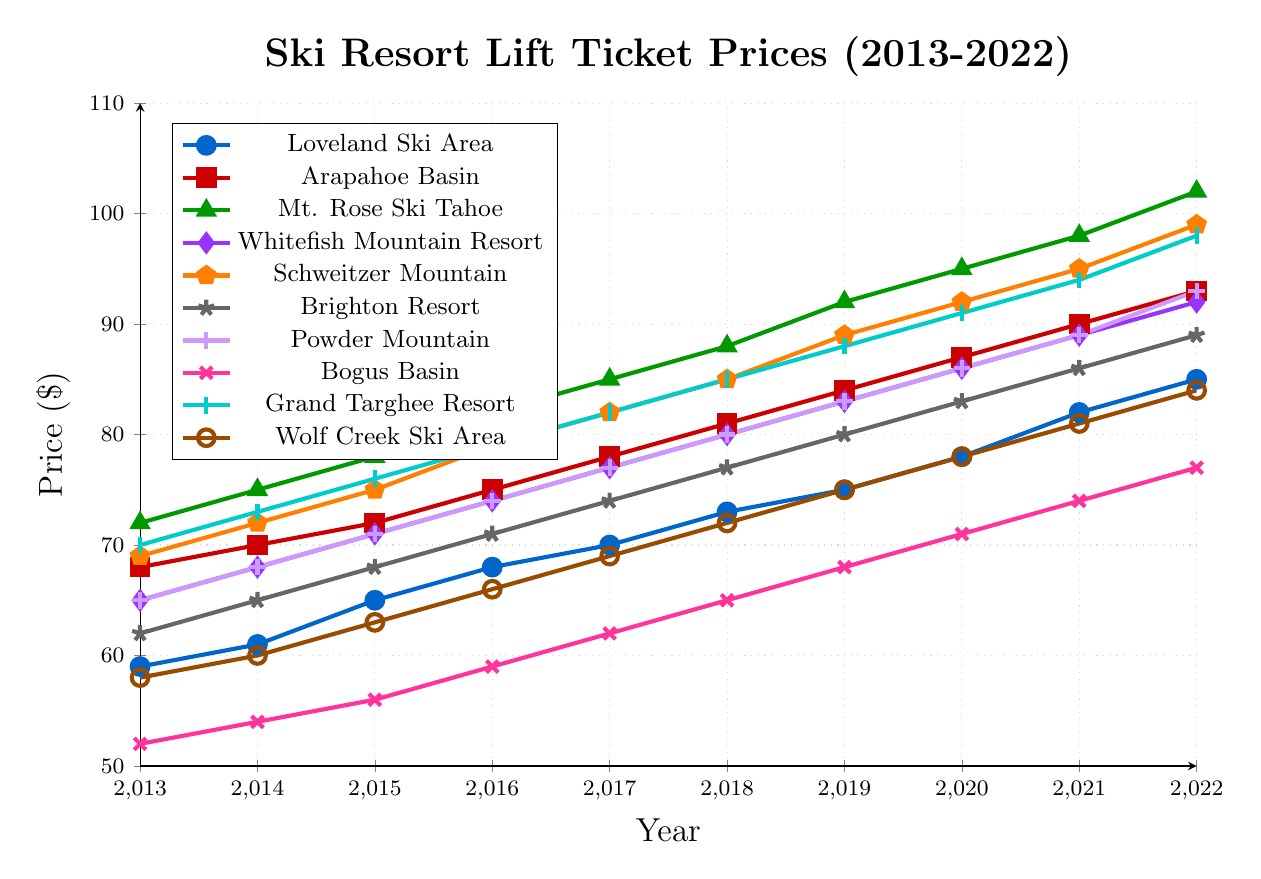Which resort had the lowest lift ticket price in 2013? Look for the data points from 2013 and identify the lowest value among them. Bogus Basin has the lowest ticket price in 2013 at $52.
Answer: Bogus Basin Which resort had the highest lift ticket price increase between 2013 and 2022? Calculate the difference between the 2022 and 2013 prices for all resorts. The largest increase is for Mt. Rose Ski Tahoe, which increased from $72 to $102, a $30 increase.
Answer: Mt. Rose Ski Tahoe What's the average lift ticket price for Loveland Ski Area over the 10 years? Sum up the prices for Loveland Ski Area from 2013 to 2022 and divide by 10. The sum is 716 and the average is 716/10 = 71.6.
Answer: 71.6 Which resort had more expensive lift tickets in 2022, Arapahoe Basin or Brighton Resort? Compare the price for Arapahoe Basin ($93) and Brighton Resort ($89) in 2022. Arapahoe Basin is more expensive.
Answer: Arapahoe Basin What is the color of the line representing Powder Mountain? Look at the legend to find the color associated with Powder Mountain. It is represented by a light purple color.
Answer: light purple Which resort had consistent lift ticket price increases every year? Check the trend lines for each resort to see if they consistently increase. All resort lines show consistent year-to-year increases, but one example is Brighton Resort.
Answer: Brighton Resort What's the difference in lift ticket prices between Loveland Ski Area and Arapahoe Basin in 2019? Subtract the 2019 price of Loveland Ski Area ($75) from that of Arapahoe Basin ($84). The difference is $9.
Answer: $9 Between Grand Targhee Resort and Schweitzer Mountain, which one had higher ticket prices in 2017? Compare the 2017 prices for Grand Targhee Resort ($82) and Schweitzer Mountain ($82). Schweitzer Mountain also has $82.
Answer: Equal Which resort had the smallest price increase between 2013 and 2022? Calculate the difference between the 2022 and 2013 prices for all resorts. Bogus Basin had the smallest increase from $52 to $77, a $25 increase.
Answer: Bogus Basin How many resorts had lift ticket prices above $90 in 2022? Count the resorts with 2022 prices above $90. Arapahoe Basin, Mt. Rose Ski Tahoe, Schweitzer Mountain, Powder Mountain, and Grand Targhee Resort had prices above $90. Total count is 5.
Answer: 5 